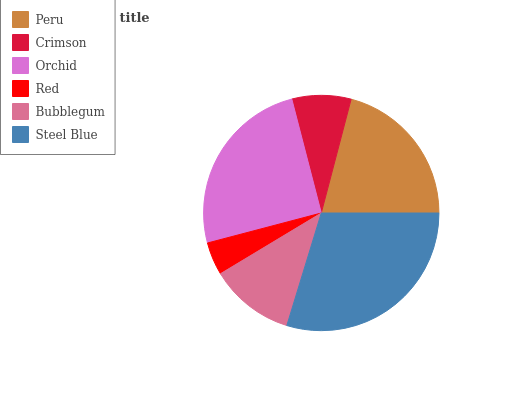Is Red the minimum?
Answer yes or no. Yes. Is Steel Blue the maximum?
Answer yes or no. Yes. Is Crimson the minimum?
Answer yes or no. No. Is Crimson the maximum?
Answer yes or no. No. Is Peru greater than Crimson?
Answer yes or no. Yes. Is Crimson less than Peru?
Answer yes or no. Yes. Is Crimson greater than Peru?
Answer yes or no. No. Is Peru less than Crimson?
Answer yes or no. No. Is Peru the high median?
Answer yes or no. Yes. Is Bubblegum the low median?
Answer yes or no. Yes. Is Red the high median?
Answer yes or no. No. Is Red the low median?
Answer yes or no. No. 